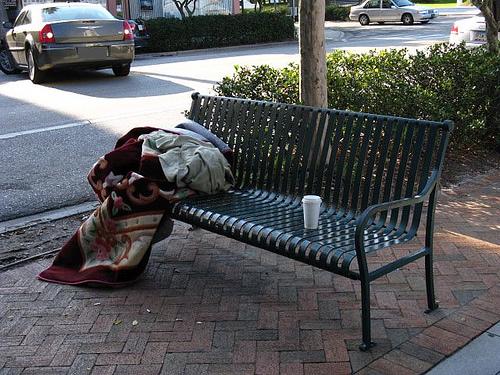What color is the bench?
Answer briefly. Green. What is on the bench?
Quick response, please. Cup. Did someone sleep on the bench?
Give a very brief answer. Yes. What is behind the bench?
Write a very short answer. Tree. How many people are sitting on this bench?
Short answer required. 0. 